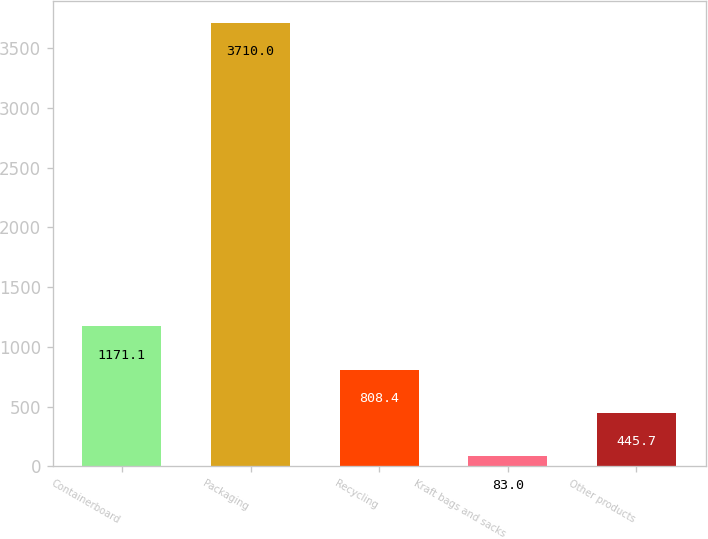Convert chart to OTSL. <chart><loc_0><loc_0><loc_500><loc_500><bar_chart><fcel>Containerboard<fcel>Packaging<fcel>Recycling<fcel>Kraft bags and sacks<fcel>Other products<nl><fcel>1171.1<fcel>3710<fcel>808.4<fcel>83<fcel>445.7<nl></chart> 